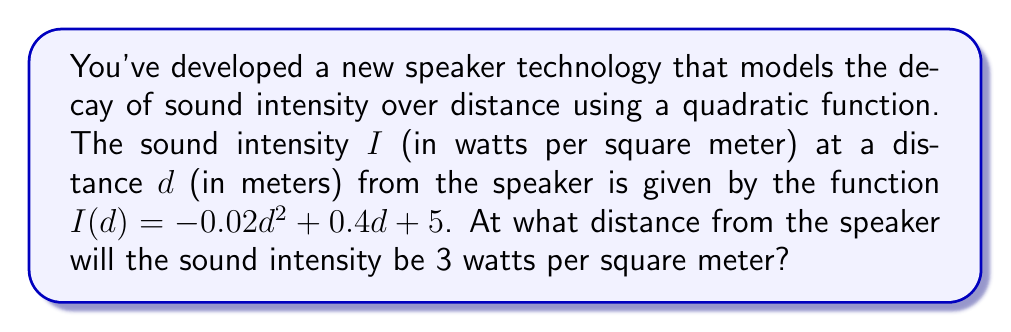What is the answer to this math problem? To find the distance at which the sound intensity is 3 watts per square meter, we need to solve the quadratic equation:

$$-0.02d^2 + 0.4d + 5 = 3$$

Let's solve this step-by-step:

1) First, rearrange the equation to standard form $(ad^2 + bd + c = 0)$:
   $$-0.02d^2 + 0.4d + 2 = 0$$

2) Identify the coefficients:
   $a = -0.02$, $b = 0.4$, $c = 2$

3) Use the quadratic formula: $d = \frac{-b \pm \sqrt{b^2 - 4ac}}{2a}$

4) Substitute the values:
   $$d = \frac{-0.4 \pm \sqrt{0.4^2 - 4(-0.02)(2)}}{2(-0.02)}$$

5) Simplify:
   $$d = \frac{-0.4 \pm \sqrt{0.16 + 0.16}}{-0.04} = \frac{-0.4 \pm \sqrt{0.32}}{-0.04}$$

6) Simplify further:
   $$d = \frac{-0.4 \pm 0.5656}{-0.04}$$

7) This gives us two solutions:
   $$d_1 = \frac{-0.4 + 0.5656}{-0.04} \approx 4.14$$
   $$d_2 = \frac{-0.4 - 0.5656}{-0.04} \approx 24.14$$

Since distance cannot be negative, and we're looking for the closest point where the intensity is 3 watts per square meter, we choose the smaller positive solution.
Answer: 4.14 meters 